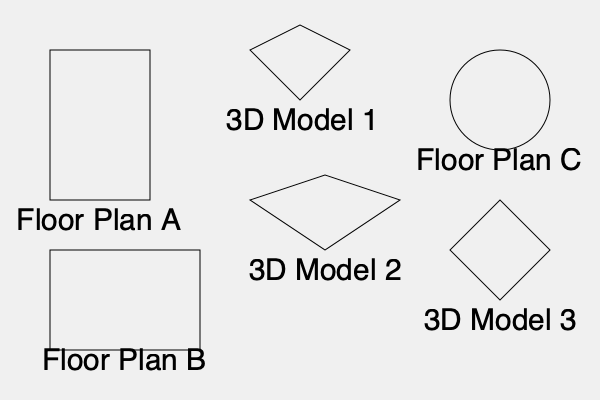Match the floor plans (A, B, C) to the corresponding 3D models (1, 2, 3) of cathedrals from different post-Soviet countries. Which combination correctly pairs the floor plans with their 3D representations? To match the floor plans with their corresponding 3D models, we need to analyze the shapes and proportions of each:

1. Floor Plan A: Rectangular shape, longer in the vertical direction.
   3D Model 1: Shows a structure with a pointed top and a longer vertical axis.
   These match, as the 3D model represents a typical Gothic-style cathedral with a rectangular base and a high, pointed roof.

2. Floor Plan B: Rectangular shape, longer in the horizontal direction.
   3D Model 2: Depicts a structure with a longer horizontal axis and a lower, more gradual roof slope.
   These correspond, as the 3D model shows a cathedral with a wider, more horizontal emphasis, common in some Eastern Orthodox churches.

3. Floor Plan C: Circular shape.
   3D Model 3: Shows a structure with a square base and a central dome.
   These align, as the circular floor plan typically represents the base of a domed structure, common in Byzantine-style churches found in some post-Soviet regions.

Given these observations, the correct pairing is:
A - 1
B - 2
C - 3

This combination reflects the diverse architectural styles found in cathedrals across post-Soviet countries, including Gothic influences, traditional Eastern Orthodox designs, and Byzantine-inspired structures.
Answer: A-1, B-2, C-3 